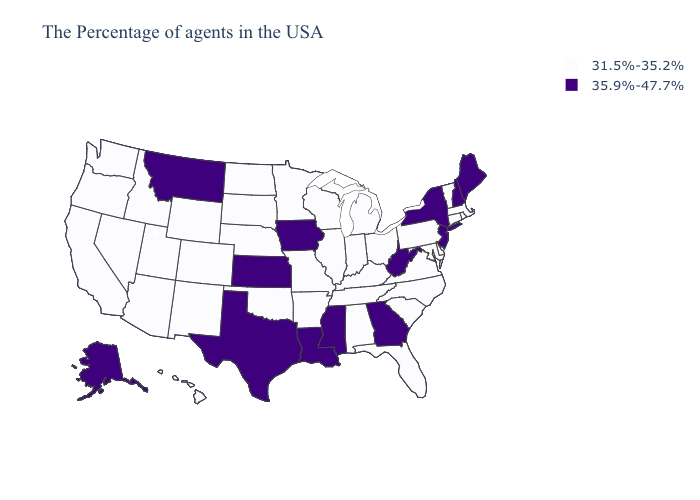What is the value of South Dakota?
Concise answer only. 31.5%-35.2%. Does Idaho have the lowest value in the West?
Write a very short answer. Yes. What is the lowest value in states that border Missouri?
Concise answer only. 31.5%-35.2%. What is the value of North Carolina?
Be succinct. 31.5%-35.2%. What is the value of Rhode Island?
Be succinct. 31.5%-35.2%. What is the value of Kentucky?
Write a very short answer. 31.5%-35.2%. Which states have the lowest value in the USA?
Short answer required. Massachusetts, Rhode Island, Vermont, Connecticut, Delaware, Maryland, Pennsylvania, Virginia, North Carolina, South Carolina, Ohio, Florida, Michigan, Kentucky, Indiana, Alabama, Tennessee, Wisconsin, Illinois, Missouri, Arkansas, Minnesota, Nebraska, Oklahoma, South Dakota, North Dakota, Wyoming, Colorado, New Mexico, Utah, Arizona, Idaho, Nevada, California, Washington, Oregon, Hawaii. Among the states that border Colorado , does Kansas have the lowest value?
Write a very short answer. No. What is the value of New Mexico?
Answer briefly. 31.5%-35.2%. What is the value of Georgia?
Answer briefly. 35.9%-47.7%. What is the value of New Hampshire?
Give a very brief answer. 35.9%-47.7%. What is the value of Ohio?
Answer briefly. 31.5%-35.2%. Does Kansas have the lowest value in the USA?
Quick response, please. No. Name the states that have a value in the range 31.5%-35.2%?
Be succinct. Massachusetts, Rhode Island, Vermont, Connecticut, Delaware, Maryland, Pennsylvania, Virginia, North Carolina, South Carolina, Ohio, Florida, Michigan, Kentucky, Indiana, Alabama, Tennessee, Wisconsin, Illinois, Missouri, Arkansas, Minnesota, Nebraska, Oklahoma, South Dakota, North Dakota, Wyoming, Colorado, New Mexico, Utah, Arizona, Idaho, Nevada, California, Washington, Oregon, Hawaii. 